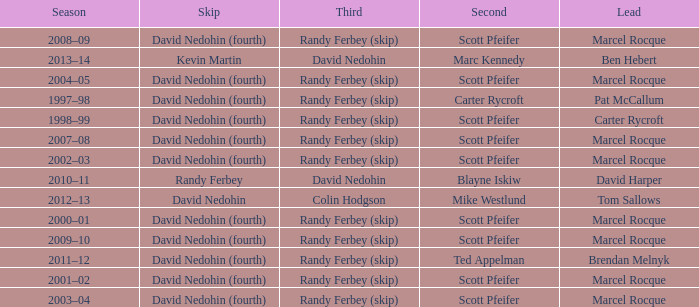Could you parse the entire table? {'header': ['Season', 'Skip', 'Third', 'Second', 'Lead'], 'rows': [['2008–09', 'David Nedohin (fourth)', 'Randy Ferbey (skip)', 'Scott Pfeifer', 'Marcel Rocque'], ['2013–14', 'Kevin Martin', 'David Nedohin', 'Marc Kennedy', 'Ben Hebert'], ['2004–05', 'David Nedohin (fourth)', 'Randy Ferbey (skip)', 'Scott Pfeifer', 'Marcel Rocque'], ['1997–98', 'David Nedohin (fourth)', 'Randy Ferbey (skip)', 'Carter Rycroft', 'Pat McCallum'], ['1998–99', 'David Nedohin (fourth)', 'Randy Ferbey (skip)', 'Scott Pfeifer', 'Carter Rycroft'], ['2007–08', 'David Nedohin (fourth)', 'Randy Ferbey (skip)', 'Scott Pfeifer', 'Marcel Rocque'], ['2002–03', 'David Nedohin (fourth)', 'Randy Ferbey (skip)', 'Scott Pfeifer', 'Marcel Rocque'], ['2010–11', 'Randy Ferbey', 'David Nedohin', 'Blayne Iskiw', 'David Harper'], ['2012–13', 'David Nedohin', 'Colin Hodgson', 'Mike Westlund', 'Tom Sallows'], ['2000–01', 'David Nedohin (fourth)', 'Randy Ferbey (skip)', 'Scott Pfeifer', 'Marcel Rocque'], ['2009–10', 'David Nedohin (fourth)', 'Randy Ferbey (skip)', 'Scott Pfeifer', 'Marcel Rocque'], ['2011–12', 'David Nedohin (fourth)', 'Randy Ferbey (skip)', 'Ted Appelman', 'Brendan Melnyk'], ['2001–02', 'David Nedohin (fourth)', 'Randy Ferbey (skip)', 'Scott Pfeifer', 'Marcel Rocque'], ['2003–04', 'David Nedohin (fourth)', 'Randy Ferbey (skip)', 'Scott Pfeifer', 'Marcel Rocque']]} Which Third has a Second of scott pfeifer? Randy Ferbey (skip), Randy Ferbey (skip), Randy Ferbey (skip), Randy Ferbey (skip), Randy Ferbey (skip), Randy Ferbey (skip), Randy Ferbey (skip), Randy Ferbey (skip), Randy Ferbey (skip). 